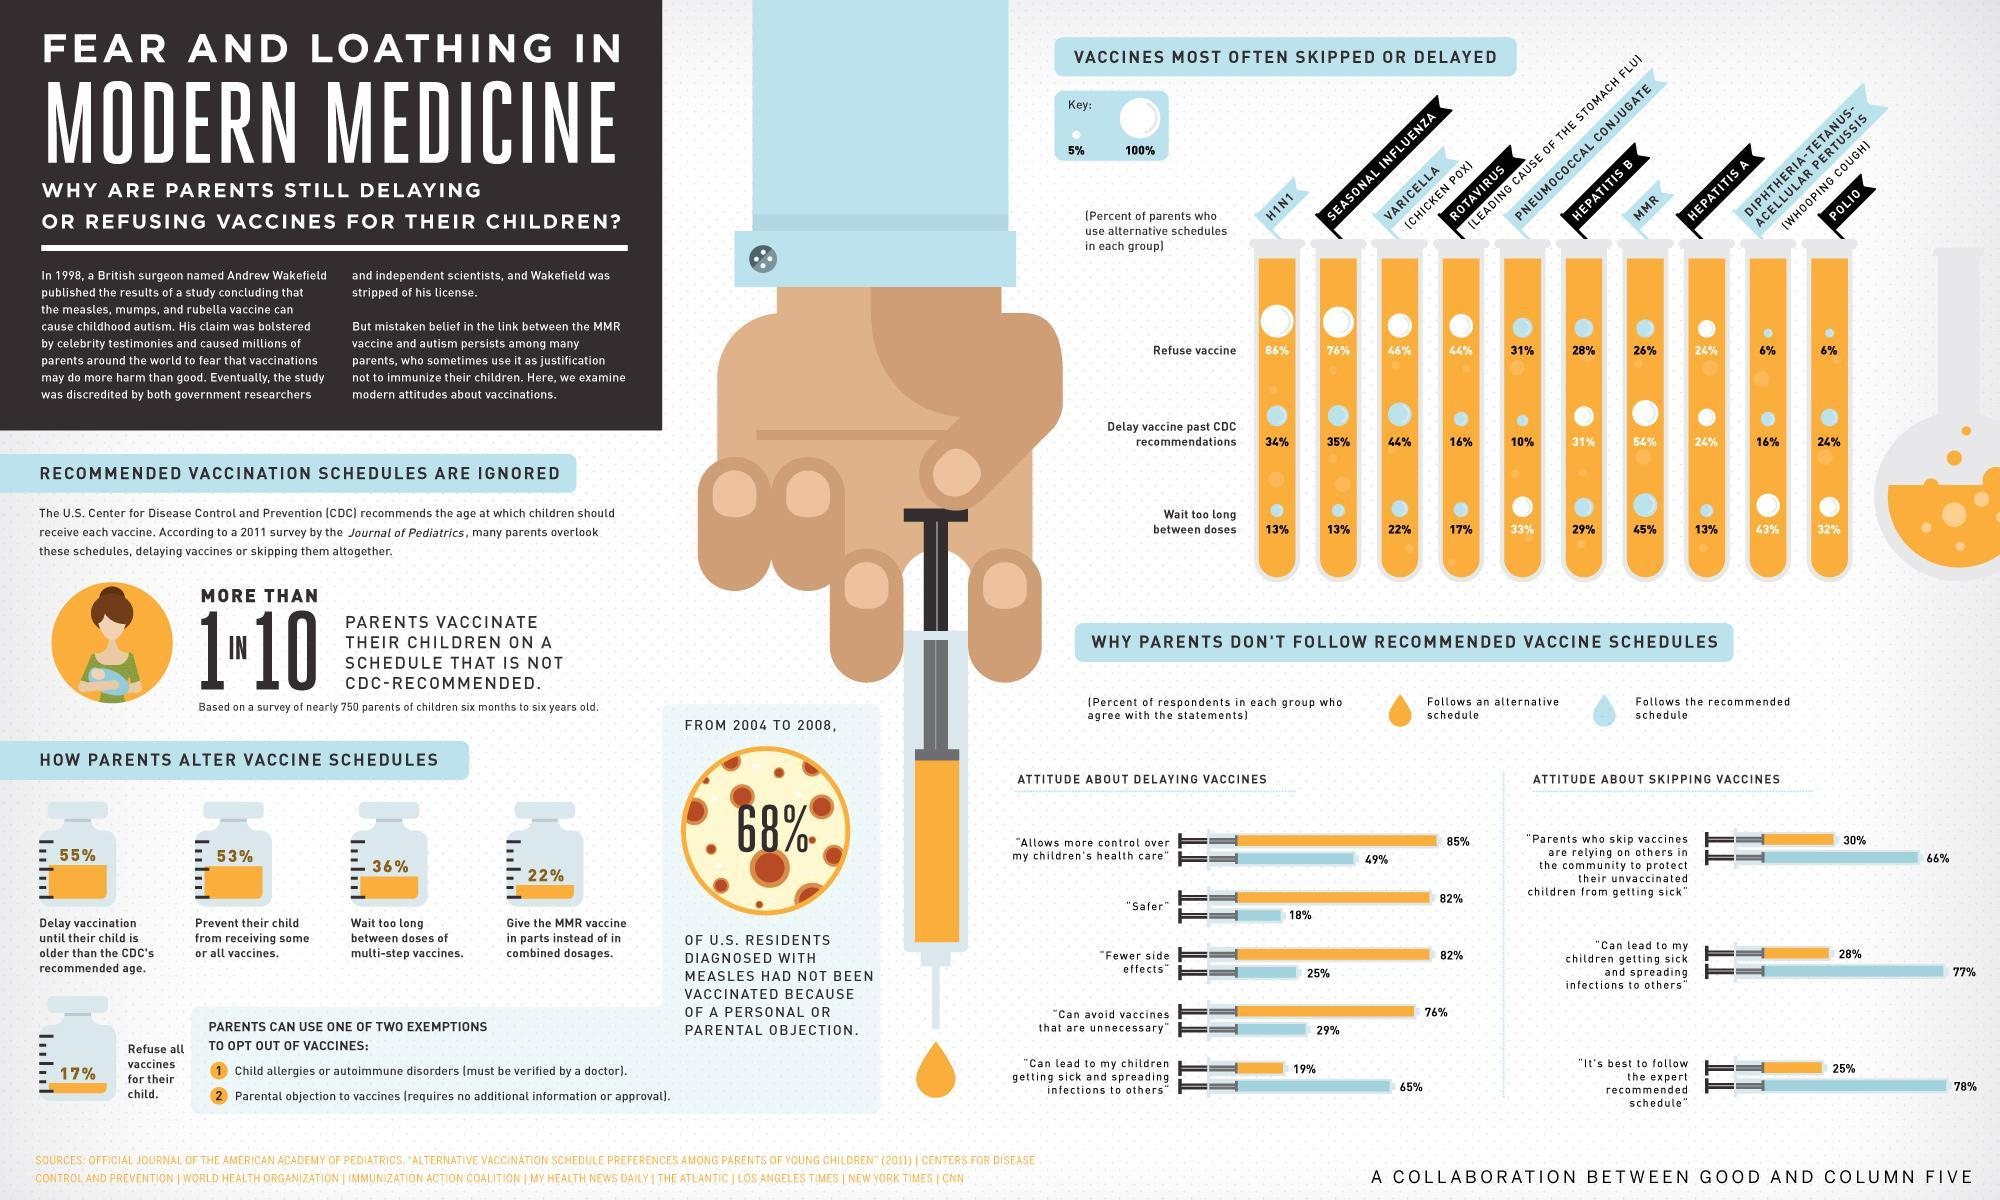Which is the most commonly skipped vaccine in the children aged 6 months to six-year-old in the U.S. according to the survey?
Answer the question with a short phrase. HINI What percent of U.S. parents waited too long between MMR vaccine doses for their children according to the survey? 45% What percent of U.S. parents  prevent their child from receiving some or all vaccines according to the survey? 53% What percent of U.S. parents  give the MMR vaccine in parts instead of in combined dosages according to the survey? 22% What percent of U.S. parents  delay Varicella vaccine for theirs children past CDC recommendations as per the survey? 44% What percent of U.S. parents delay vaccination until their child is older than the CDC's recommended age according to the survey? 55% What percent of U.S. parents refuse Polio vaccine for their child according to the survey? 6% What percent of U.S. parents refuse Hepatitis B vaccine for their children  according to the survey? 28% 